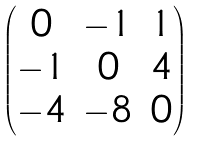<formula> <loc_0><loc_0><loc_500><loc_500>\begin{pmatrix} 0 & - 1 & 1 \\ - 1 & 0 & 4 \\ - 4 & - 8 & 0 \end{pmatrix}</formula> 